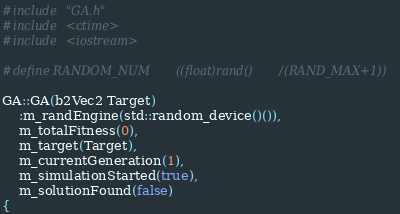<code> <loc_0><loc_0><loc_500><loc_500><_C++_>#include "GA.h"
#include <ctime>
#include <iostream>

#define RANDOM_NUM		((float)rand()/(RAND_MAX+1))

GA::GA(b2Vec2 Target)
	:m_randEngine(std::random_device()()),
	m_totalFitness(0),
	m_target(Target),
	m_currentGeneration(1),
	m_simulationStarted(true),
	m_solutionFound(false)
{</code> 